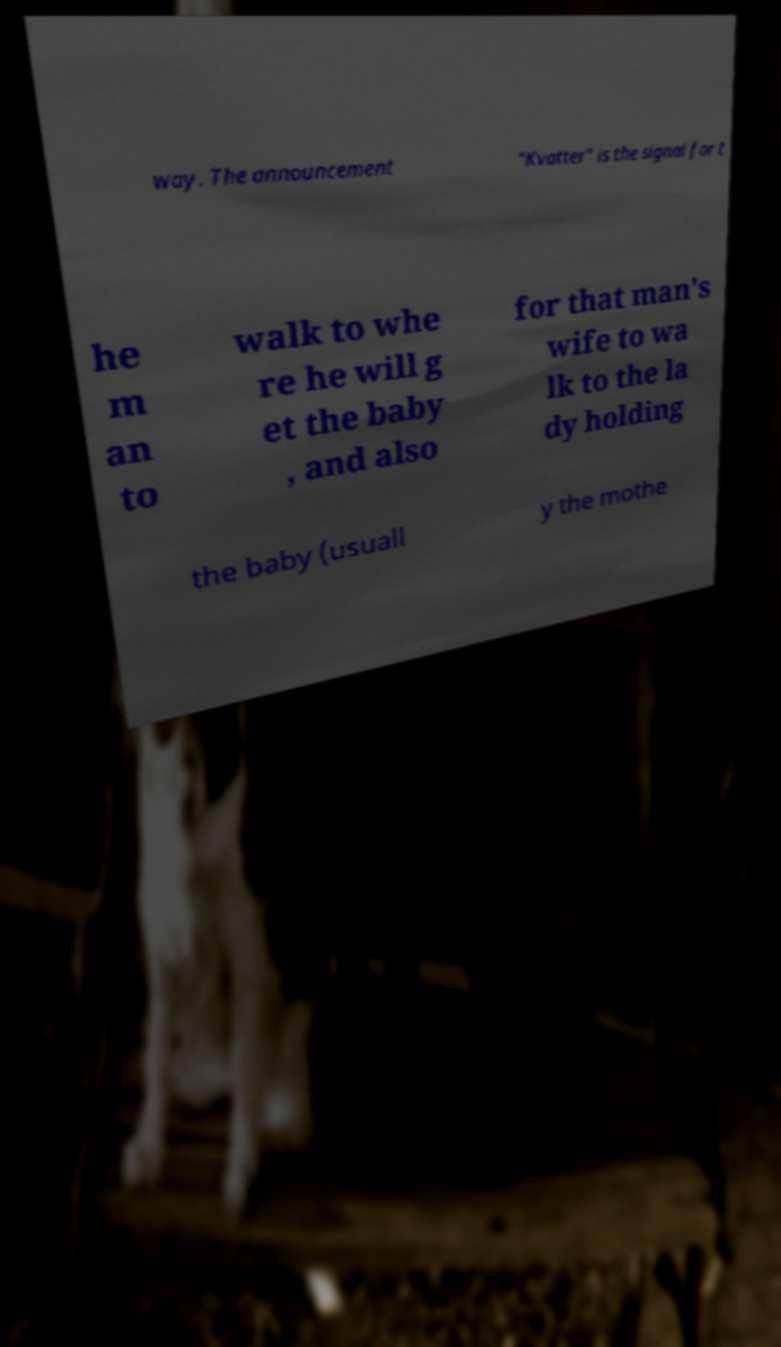There's text embedded in this image that I need extracted. Can you transcribe it verbatim? way. The announcement "Kvatter" is the signal for t he m an to walk to whe re he will g et the baby , and also for that man's wife to wa lk to the la dy holding the baby (usuall y the mothe 